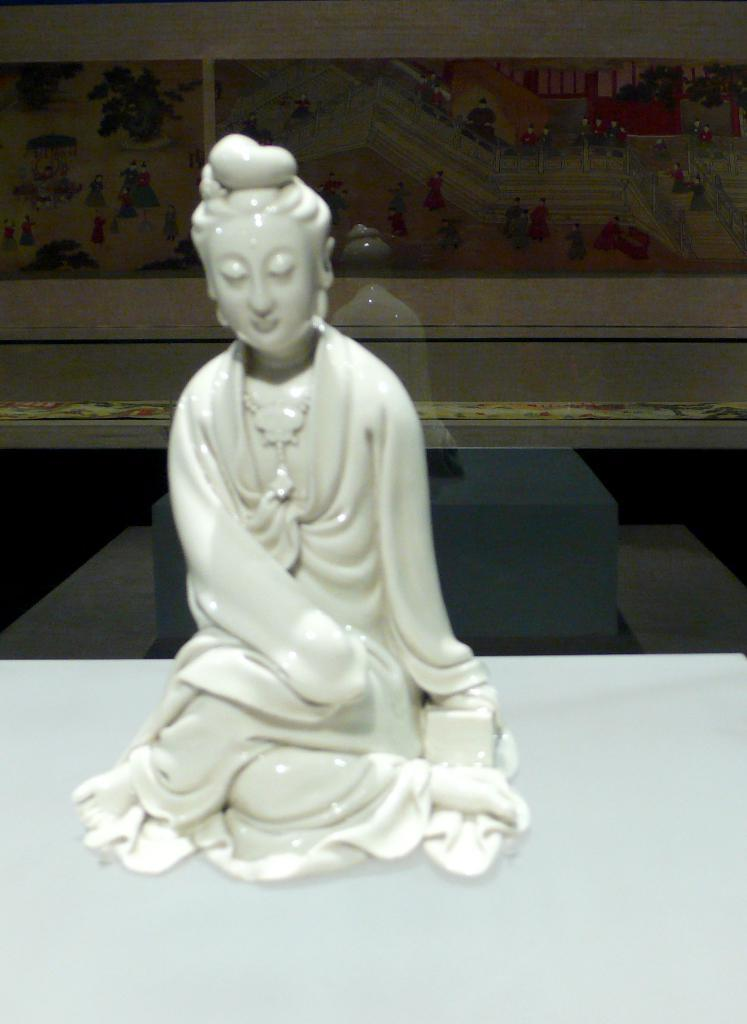What is the main subject on the table in the image? There is a statue on a table in the image. What is located behind the statue on the table? There is a glass with a painting on it behind the statue. What invention can be seen in the image? There is no invention present in the image; it features a statue on a table and a glass with a painting behind the statue. What type of voice can be heard coming from the statue in the image? There is no voice or sound coming from the statue in the image. 